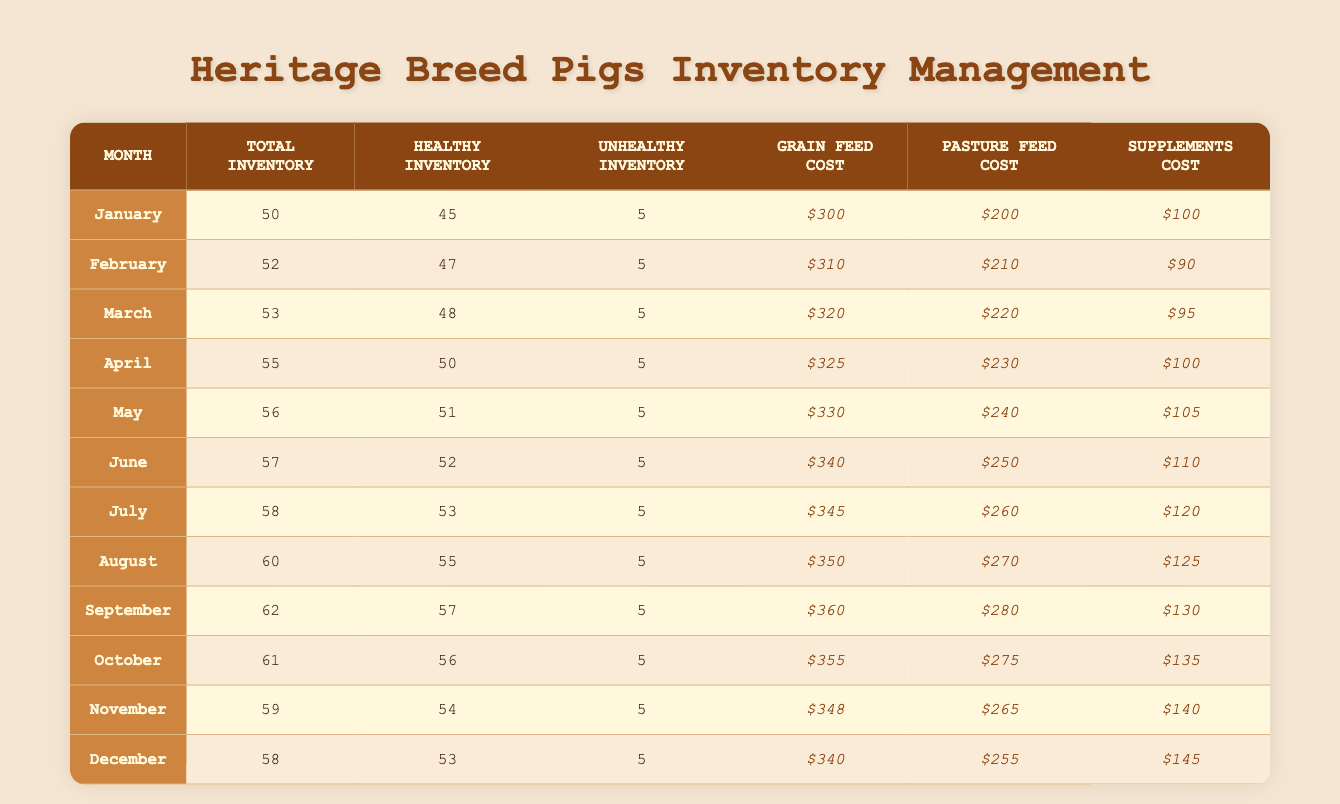What is the total inventory of heritage breed pigs in August? Referring to the table, the total inventory for August is listed in the corresponding row. The total inventory for August is 60.
Answer: 60 How many healthy heritage breed pigs were there in June? Looking at the June row, the number of healthy pigs is directly provided under the "Healthy Inventory" column, which is 52.
Answer: 52 What were the feed costs for supplements in March? The row for March specifies the feed costs, where the cost for supplements is found under the "Supplements Cost" column. The cost is $95.
Answer: $95 Which month had the highest feed cost for grain? Review the "Grain Feed Cost" column across all the months to find the maximum value. In September, the grain feed cost is $360, which is the highest.
Answer: September What is the average total inventory of pigs for the months from April to July? Calculate the total inventory for April (55), May (56), June (57), and July (58). The sum is (55 + 56 + 57 + 58) = 226. There are 4 months, so the average is 226/4 = 56.5.
Answer: 56.5 In which month did the number of healthy pigs equal 54? By checking each row, November lists the healthy inventory as 54, making it the month in which that number applies.
Answer: November Is the total inventory in October greater than that in January? Comparing the two months, October has a total inventory of 61 while January has 50, confirming that October is indeed greater.
Answer: Yes What is the variance in the total inventory of pigs from January to December? Calculate the difference between each month's total inventory. January (50) to December (58) gives a variation of (58 - 50) = 8. The variance is simply the range, so the answer is 8.
Answer: 8 How much more was spent on pasture feed in June compared to April? In June, the pasture feed cost is $250 and in April, it is $230. The difference is calculated as (250 - 230) = 20.
Answer: 20 What was the total unhealthy inventory of pigs throughout the entire year? Since the unhealthy inventory is consistent at 5 pigs from January to December, multiply the monthly count (5) by the count of months (12): 5 * 12 = 60.
Answer: 60 